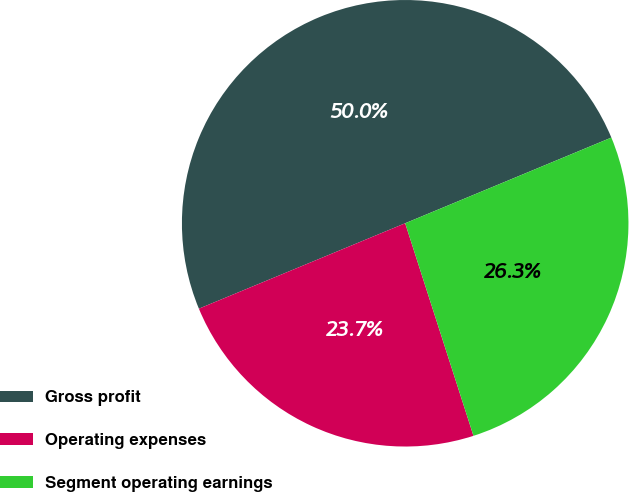Convert chart. <chart><loc_0><loc_0><loc_500><loc_500><pie_chart><fcel>Gross profit<fcel>Operating expenses<fcel>Segment operating earnings<nl><fcel>49.98%<fcel>23.7%<fcel>26.32%<nl></chart> 